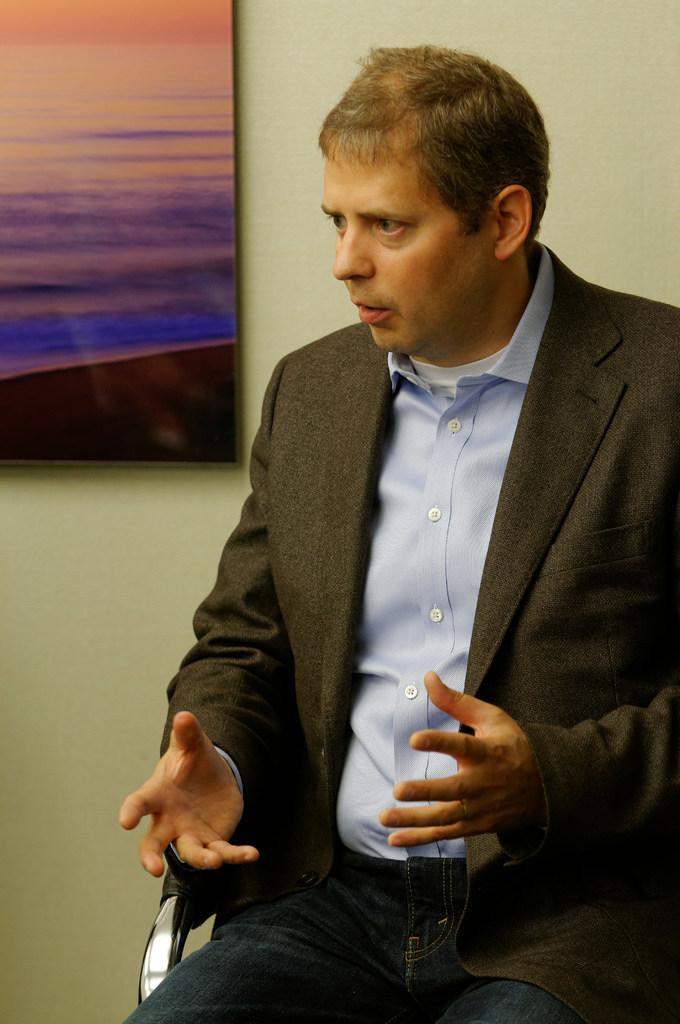What is the man in the image doing? The man is sitting in the image. Where is the man located in the image? The man is in the foreground area of the image. What can be seen in the background of the image? There is a frame in the background of the image. What type of egg is being whipped in the oven in the image? There is no oven, egg, or whipping activity present in the image. 